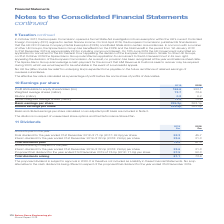According to Spirax Sarco Engineering Plc's financial document, What is the Total dividends paid for 2019? According to the financial document, 75.9 (in millions). The relevant text states: ": 29.0p) per share 23.6 21.3 Total dividends paid 75.9 67.0 Amounts arising in respect of the year: Interim dividend for the year ended 31st December 2019..." Also, When is the proposed dividend subject to be approved? According to the financial document, 2020. The relevant text states: "& Customs seek to recover may be required during 2020, which we would expect to be refundable in the event of a successful appeal...." Also, For which years are the amounts of total dividends paid calculated? The document shows two values: 2019 and 2018. From the document: "2019 2018 Profit attributable to equity shareholders (£m) 166.6 223.1 Weighted average shares (million) 2019 2018 Profit attributable to equity shareh..." Additionally, In which year was the total dividends paid larger? According to the financial document, 2019. The relevant text states: "2019 2018 Profit attributable to equity shareholders (£m) 166.6 223.1 Weighted average shares (million)..." Also, can you calculate: What was the change in the amount of total dividends paid in 2019 from 2018? Based on the calculation: 75.9-67.0, the result is 8.9 (in millions). This is based on the information: "0p) per share 23.6 21.3 Total dividends paid 75.9 67.0 Amounts arising in respect of the year: Interim dividend for the year ended 31st December 2019 of 3 : 29.0p) per share 23.6 21.3 Total dividends ..." The key data points involved are: 67.0, 75.9. Also, can you calculate: What was the percentage change in the amount of total dividends paid in 2019 from 2018? To answer this question, I need to perform calculations using the financial data. The calculation is: (75.9-67.0)/67.0, which equals 13.28 (percentage). This is based on the information: "0p) per share 23.6 21.3 Total dividends paid 75.9 67.0 Amounts arising in respect of the year: Interim dividend for the year ended 31st December 2019 of 3 : 29.0p) per share 23.6 21.3 Total dividends ..." The key data points involved are: 67.0, 75.9. 